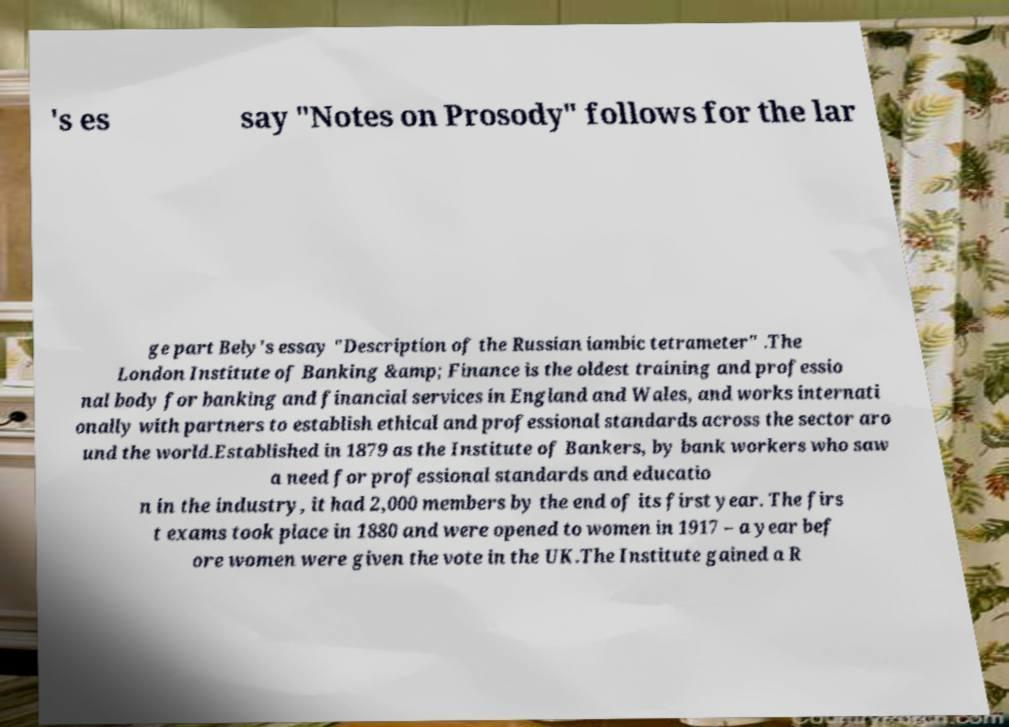Can you accurately transcribe the text from the provided image for me? 's es say "Notes on Prosody" follows for the lar ge part Bely's essay "Description of the Russian iambic tetrameter" .The London Institute of Banking &amp; Finance is the oldest training and professio nal body for banking and financial services in England and Wales, and works internati onally with partners to establish ethical and professional standards across the sector aro und the world.Established in 1879 as the Institute of Bankers, by bank workers who saw a need for professional standards and educatio n in the industry, it had 2,000 members by the end of its first year. The firs t exams took place in 1880 and were opened to women in 1917 – a year bef ore women were given the vote in the UK.The Institute gained a R 